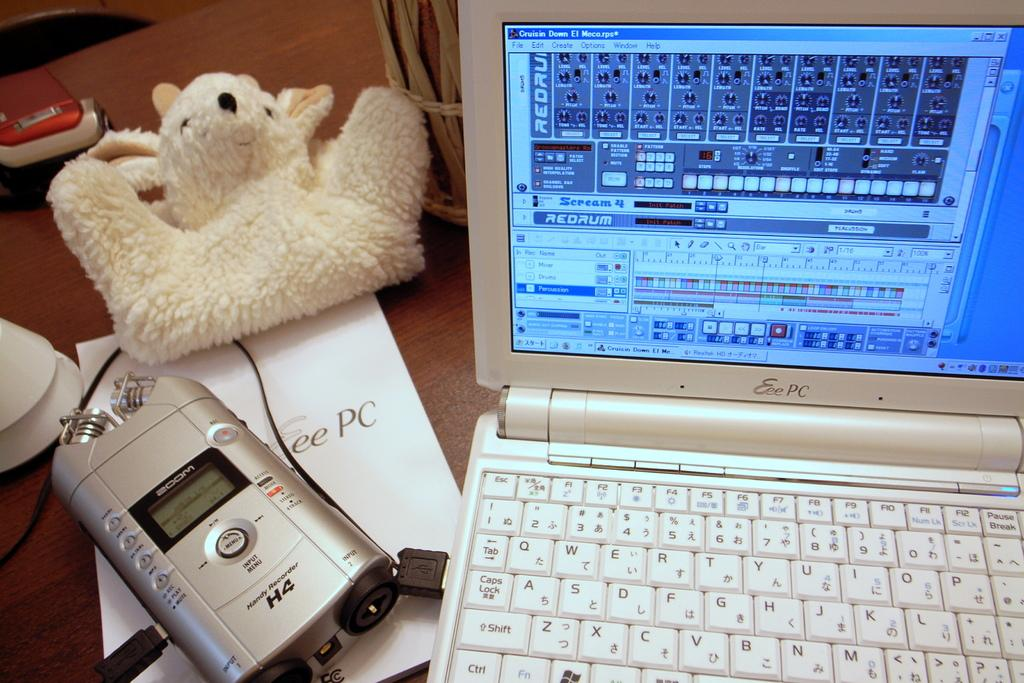<image>
Share a concise interpretation of the image provided. An open laptop sets on the right and a H4 silver device on the left. 